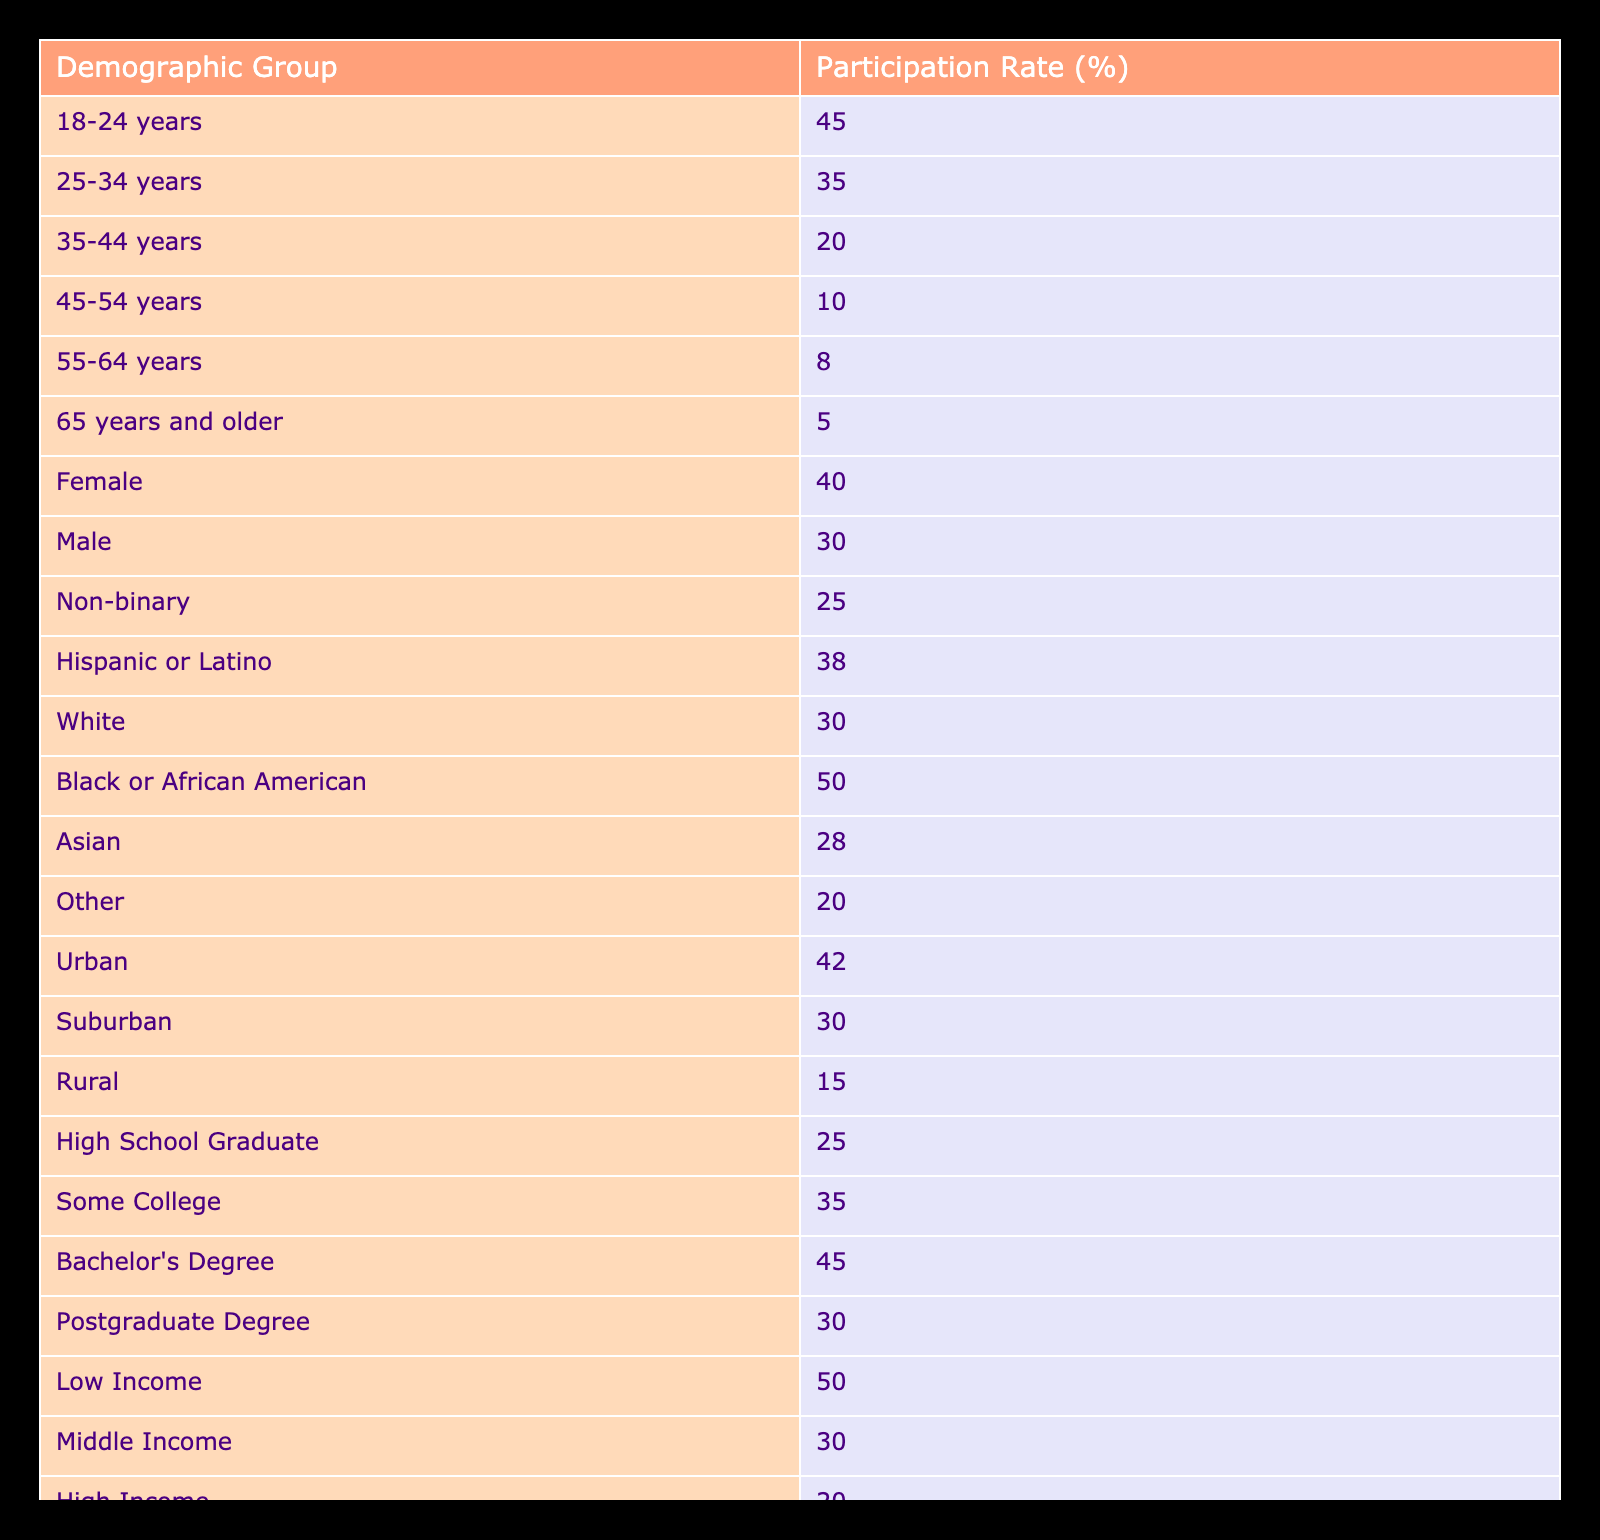What is the participation rate for the 18-24 age group? The table lists the participation rate for the 18-24 age group directly as 45%.
Answer: 45% What is the participation rate for Black or African American individuals? According to the table, the participation rate for Black or African American individuals is 50%.
Answer: 50% Which demographic has the lowest participation rate? By reviewing the table, the demographic group with the lowest participation rate is those aged 65 years and older, with a rate of 5%.
Answer: 5% What is the difference in participation rates between rural and urban populations? The table shows the participation rate for urban populations at 42% and for rural populations at 15%. To find the difference, subtract 15 from 42, which gives 27%.
Answer: 27% Is the participation rate for males greater than that for non-binary individuals? The table indicates that the participation rate for males is 30% and for non-binary individuals is 25%. Since 30% is greater than 25%, the answer is yes.
Answer: Yes What is the average participation rate across all age groups listed in the table? The age groups and their participation rates are: 45 (18-24), 35 (25-34), 20 (35-44), 10 (45-54), 8 (55-64), and 5 (65+). Adding these rates gives a total of 123. There are 6 age groups, so the average is 123 divided by 6, which equals 20.5%.
Answer: 20.5% What is the participation rate for individuals with a Bachelor's Degree? The table specifies that the participation rate for individuals with a Bachelor's Degree is 45%.
Answer: 45% Which income bracket has the highest participation rate? The table shows that the low-income group has the highest participation rate at 50%, as compared to middle income at 30% and high income at 20%.
Answer: 50% If we combine the participation rates of the 25-34 and 35-44 age groups, what is the total participation rate? The participation rate for the 25-34 age group is 35%, and for the 35-44 age group, it is 20%. Adding both rates together (35 + 20) gives a total of 55%.
Answer: 55% 